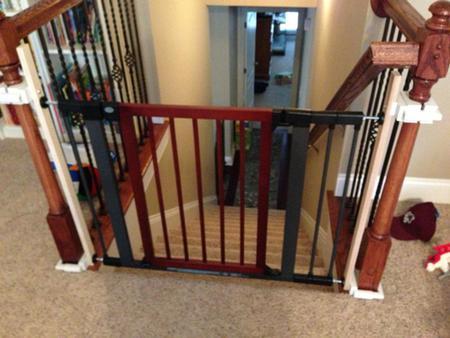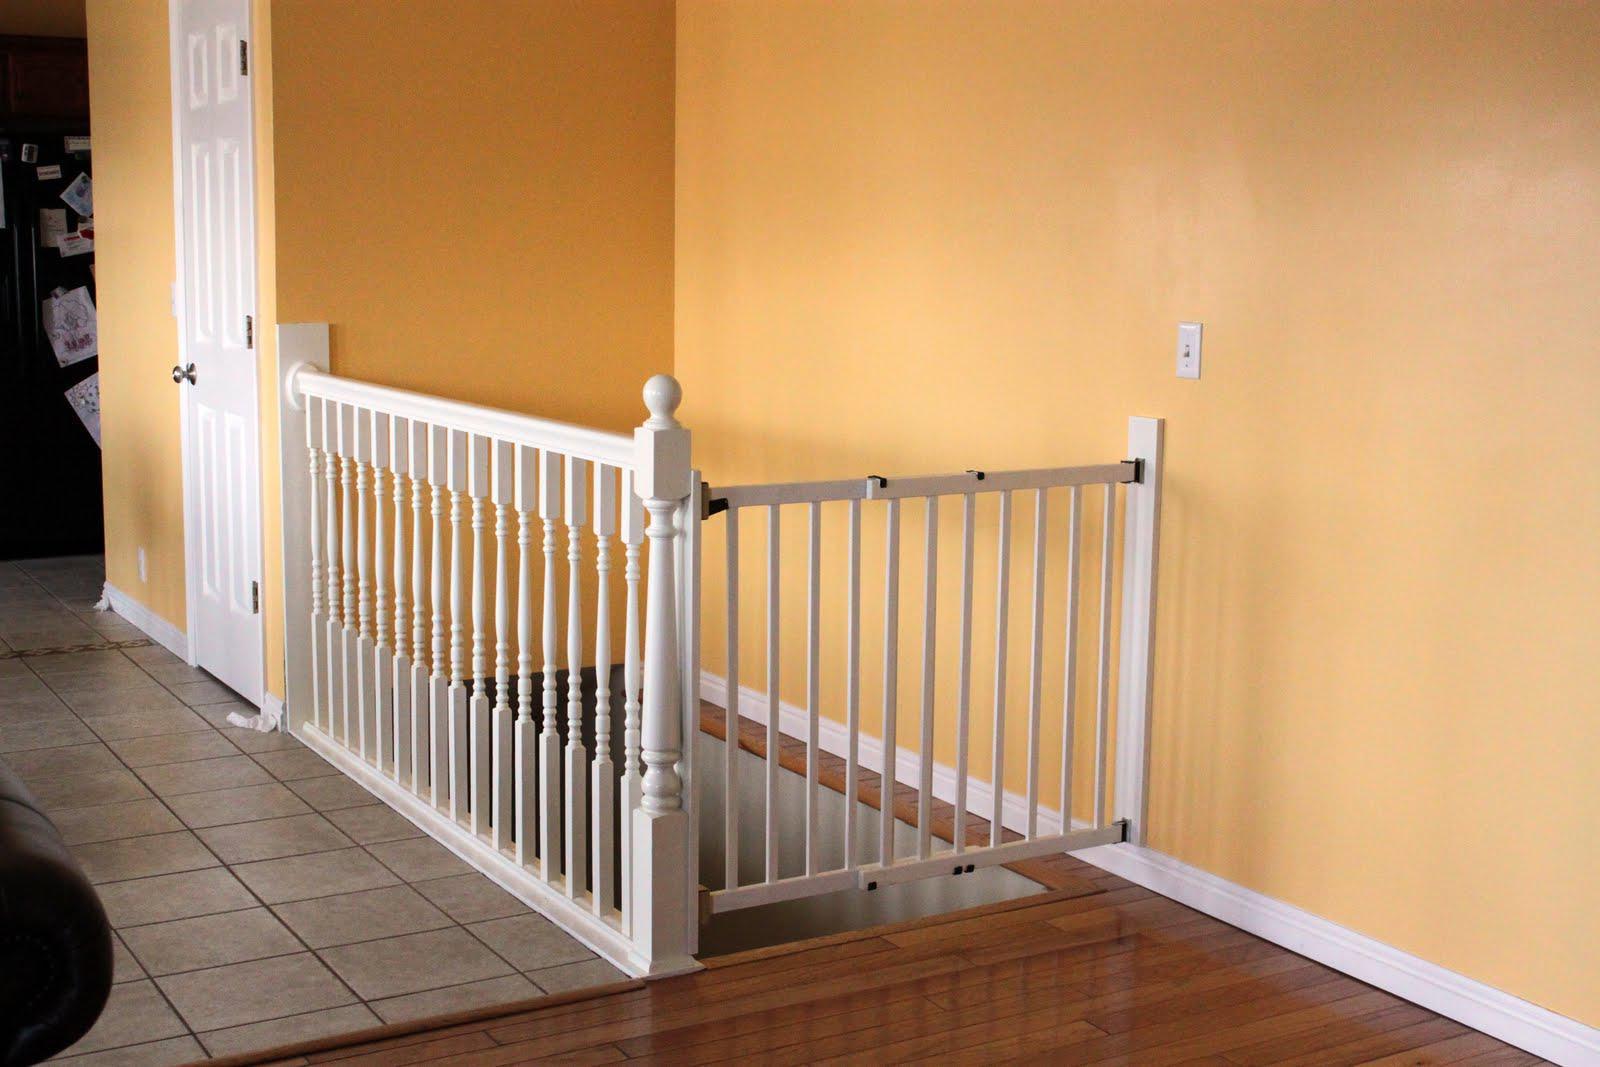The first image is the image on the left, the second image is the image on the right. Assess this claim about the two images: "Some of the floors upstairs are not carpeted.". Correct or not? Answer yes or no. Yes. The first image is the image on the left, the second image is the image on the right. Examine the images to the left and right. Is the description "The stairway posts are all dark wood." accurate? Answer yes or no. No. 